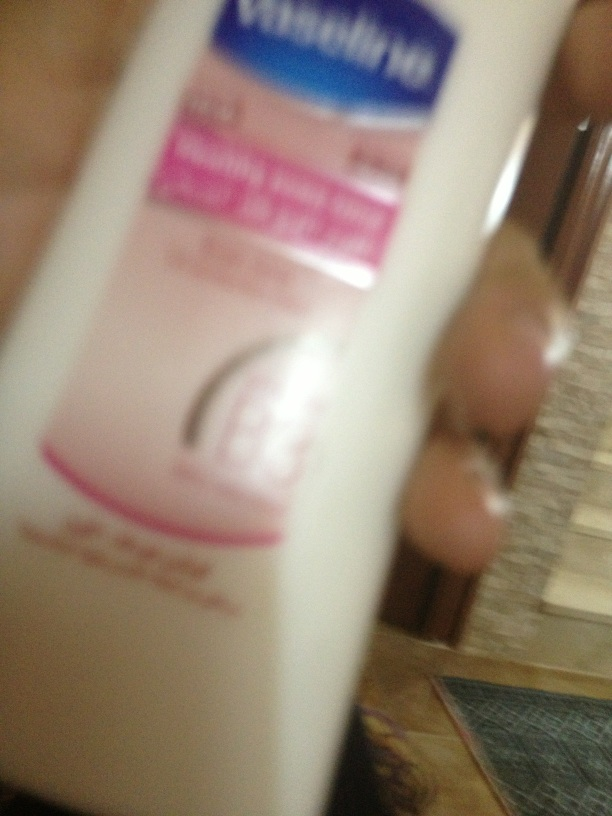How does this product compare to others available in the market? Vaseline lotion is known for its effectiveness in moisturizing and protecting the skin compared to other lotions due to its unique formulation, which includes petroleum jelly for a strong moisture barrier. Compared to other products, Vaseline is often more affordable and widely recognized for its reliability and versatility. However, different lotions offer various benefits like scent, texture, absorption rate, and ingredient specificity, so some users may prefer specialized products for particular skin needs. Can you craft a story about someone discovering the benefits of this lotion? Once upon a time, in a small, bustling city, a young woman named Lily worked long hours at a local bakery. Between the hot ovens and constant hand washing, her hands became terribly dry and cracked. One day, while picking up groceries, she stumbled upon a bottle of Vaseline lotion. Skeptical but desperate, she decided to give it a try. To her amazement, after just a few uses, her hands felt softer, smoother, and more comfortable than they had in months. The lotion not only healed her cracked hands but also protected them from the daily wear and tear of her job. Grateful, Lily started recommending it to her friends, sharing how this simple discovery had made her life so much better. Over time, she became a loyal user, and the scent of the familiar lotion always reminded her of the relief and joy it brought her. 